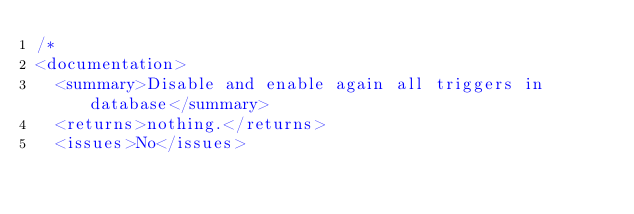<code> <loc_0><loc_0><loc_500><loc_500><_SQL_>/*
<documentation>
  <summary>Disable and enable again all triggers in database</summary>
  <returns>nothing.</returns>
  <issues>No</issues></code> 